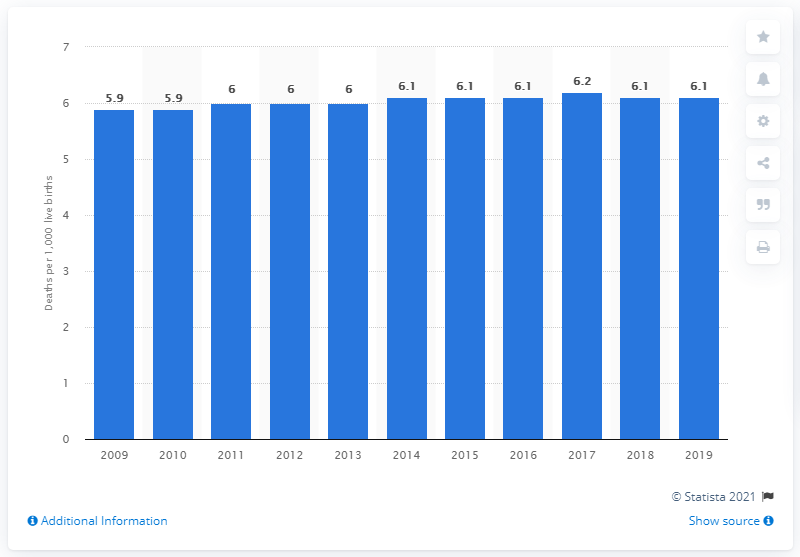Highlight a few significant elements in this photo. In 2019, the infant mortality rate in Malta was 6.1 deaths per 1,000 live births. 